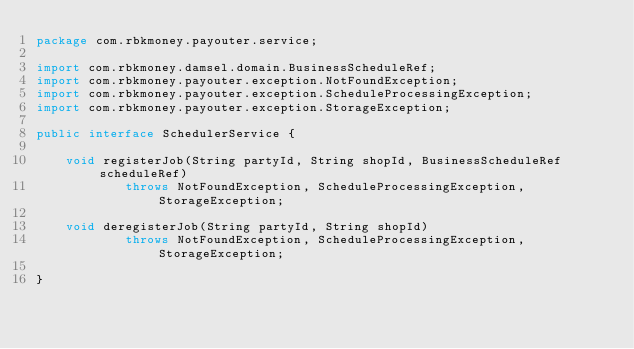<code> <loc_0><loc_0><loc_500><loc_500><_Java_>package com.rbkmoney.payouter.service;

import com.rbkmoney.damsel.domain.BusinessScheduleRef;
import com.rbkmoney.payouter.exception.NotFoundException;
import com.rbkmoney.payouter.exception.ScheduleProcessingException;
import com.rbkmoney.payouter.exception.StorageException;

public interface SchedulerService {

    void registerJob(String partyId, String shopId, BusinessScheduleRef scheduleRef)
            throws NotFoundException, ScheduleProcessingException, StorageException;

    void deregisterJob(String partyId, String shopId)
            throws NotFoundException, ScheduleProcessingException, StorageException;

}
</code> 